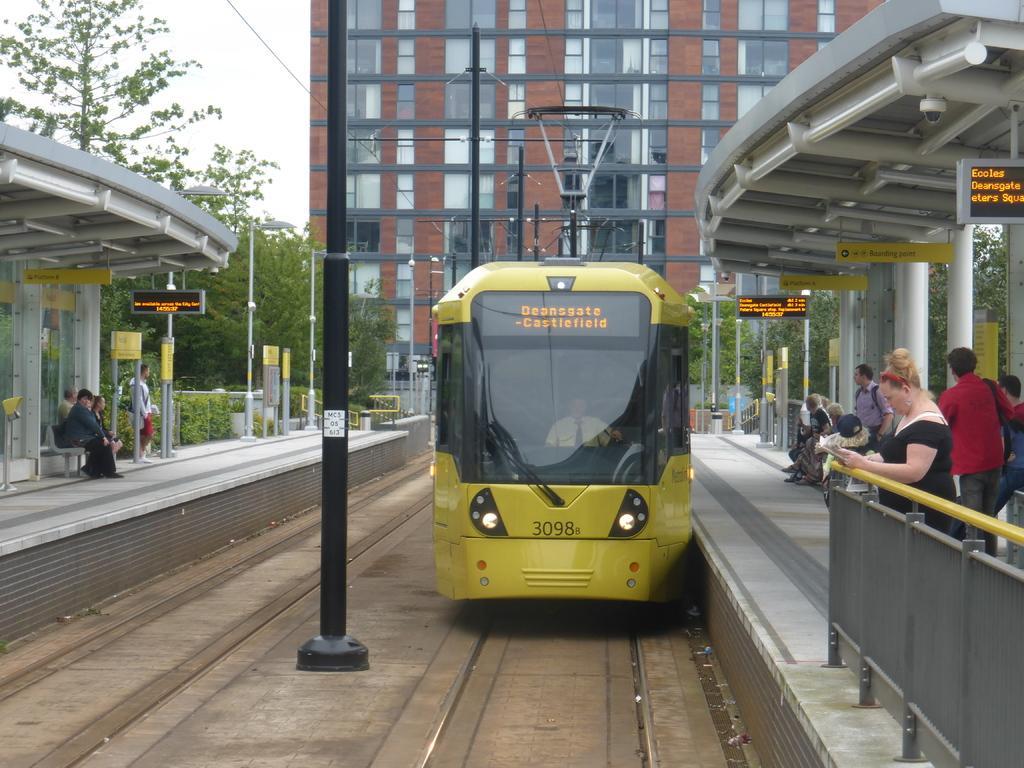Can you describe this image briefly? In this image we can see a train on a railway track to the side there is a platform where we can see some people sitting and standing. We can see some led sign boards and yellow boards with text on it. There is a building in the background and we can see some trees and plants. 